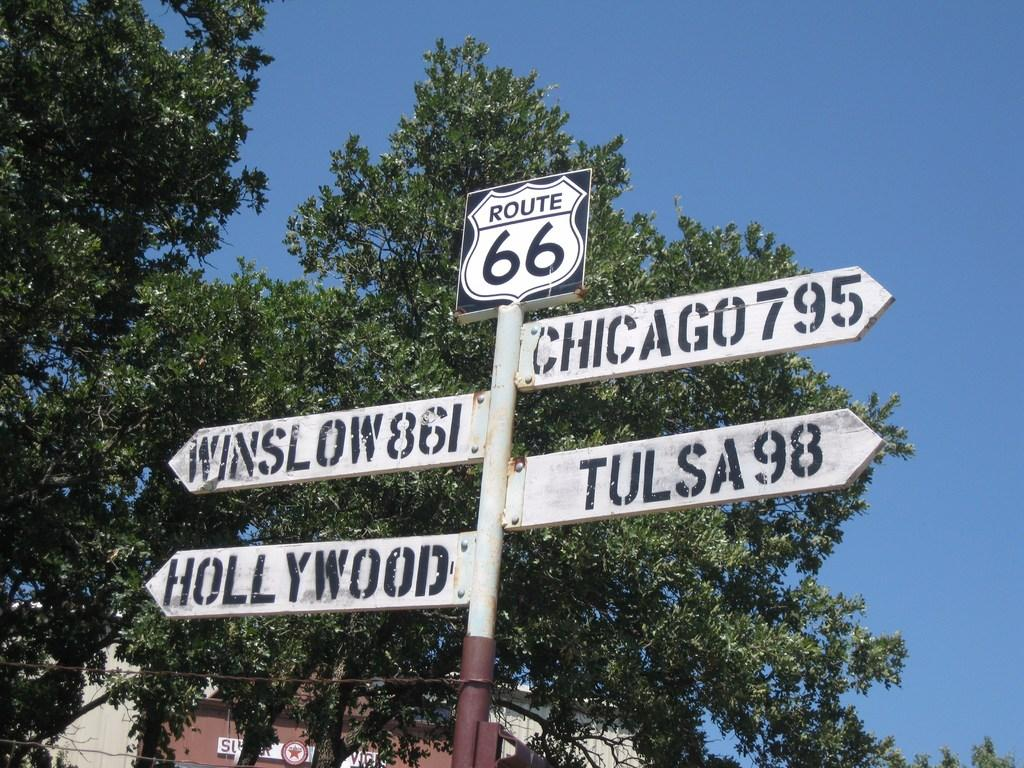What is the main object in the image? There is a sign board in the image. Where is the sign board located? The sign board is in front of trees. What can be seen in the background of the image? There is a sky visible in the background of the image. What type of guitar can be heard playing in the image? There is no guitar or sound present in the image, as it is a static image of a sign board in front of trees with a visible sky in the background. 